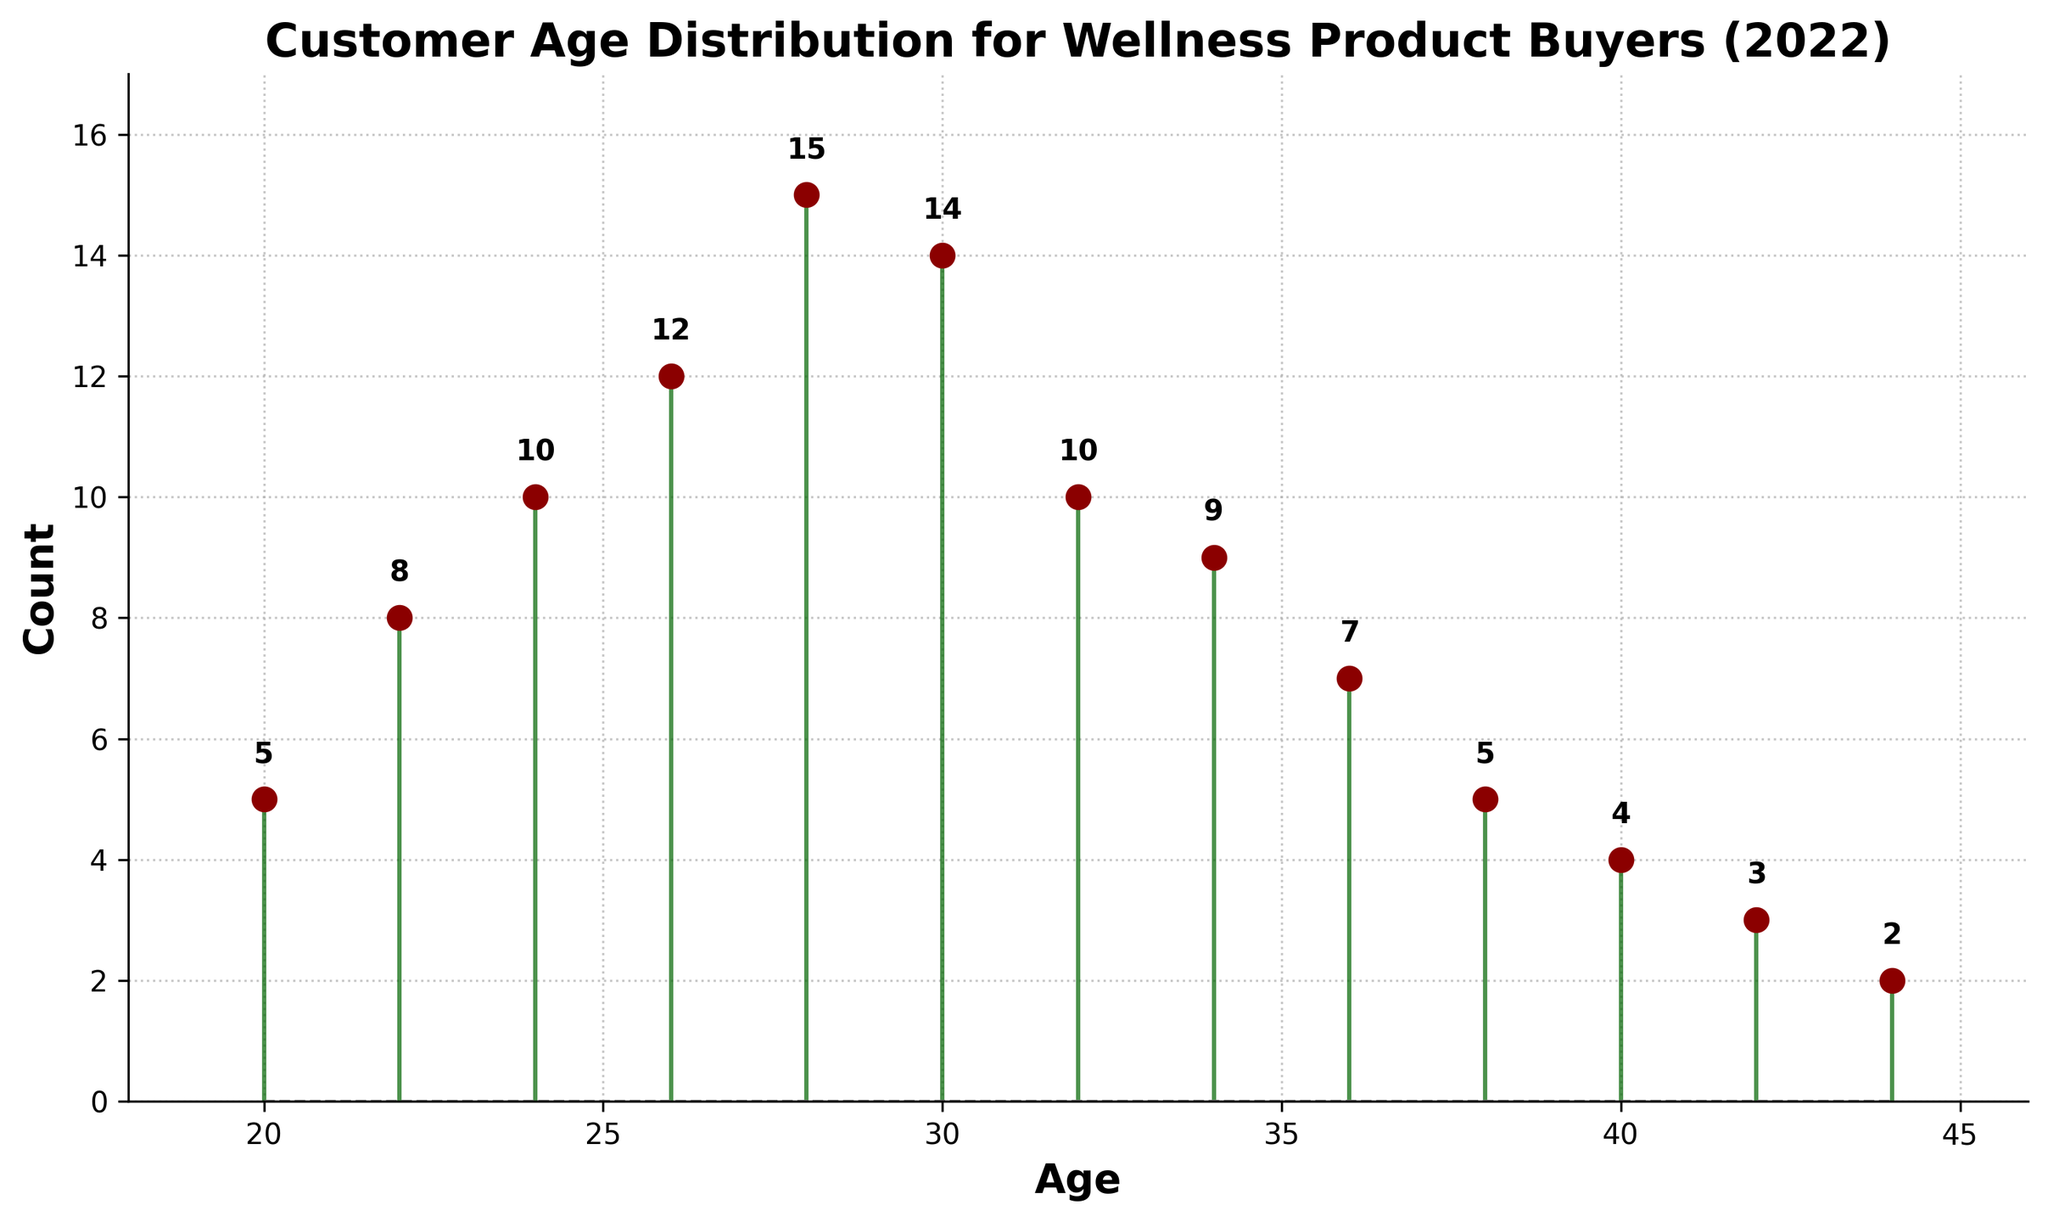What is the title of the plot? The title is prominently displayed at the top and indicates what the plot is about.
Answer: Customer Age Distribution for Wellness Product Buyers (2022) What age group has the highest count of buyers? By visually inspecting the plot, find the age with the highest vertical stem.
Answer: 28 At what age is there a significant drop in the count of buyers? Look for a steep decline in the height of the stems to identify the age where the count drops significantly.
Answer: 42 What is the total number of wellness product buyers shown in the plot? Sum all the counts from each age group: 5 + 8 + 10 + 12 + 15 + 14 + 10 + 9 + 7 + 5 + 4 + 3 + 2.
Answer: 104 Which age group shows the first count of 10 buyers? Locate the first stem that reaches a height of 10 units.
Answer: 24 What is the average count of buyers across all age groups? Calculate the total number of buyers (104) and divide by the number of age groups (13).
Answer: 8 How many age groups have more than 10 buyers? Count the number of stems that exceed the height corresponding to 10 units.
Answer: 3 Which age groups have the same count of buyers? Identify age groups with stems that reach the same height.
Answer: Ages 20 and 38 both have 5 buyers Is there any age group with less than 3 buyers? Look for any stem that is below the height corresponding to 3 units.
Answer: Yes, the age group 44 has 2 buyers What is the difference in buyer count between ages 28 and 30? Subtract the count of buyers at age 30 (14) from the count at age 28 (15).
Answer: 1 